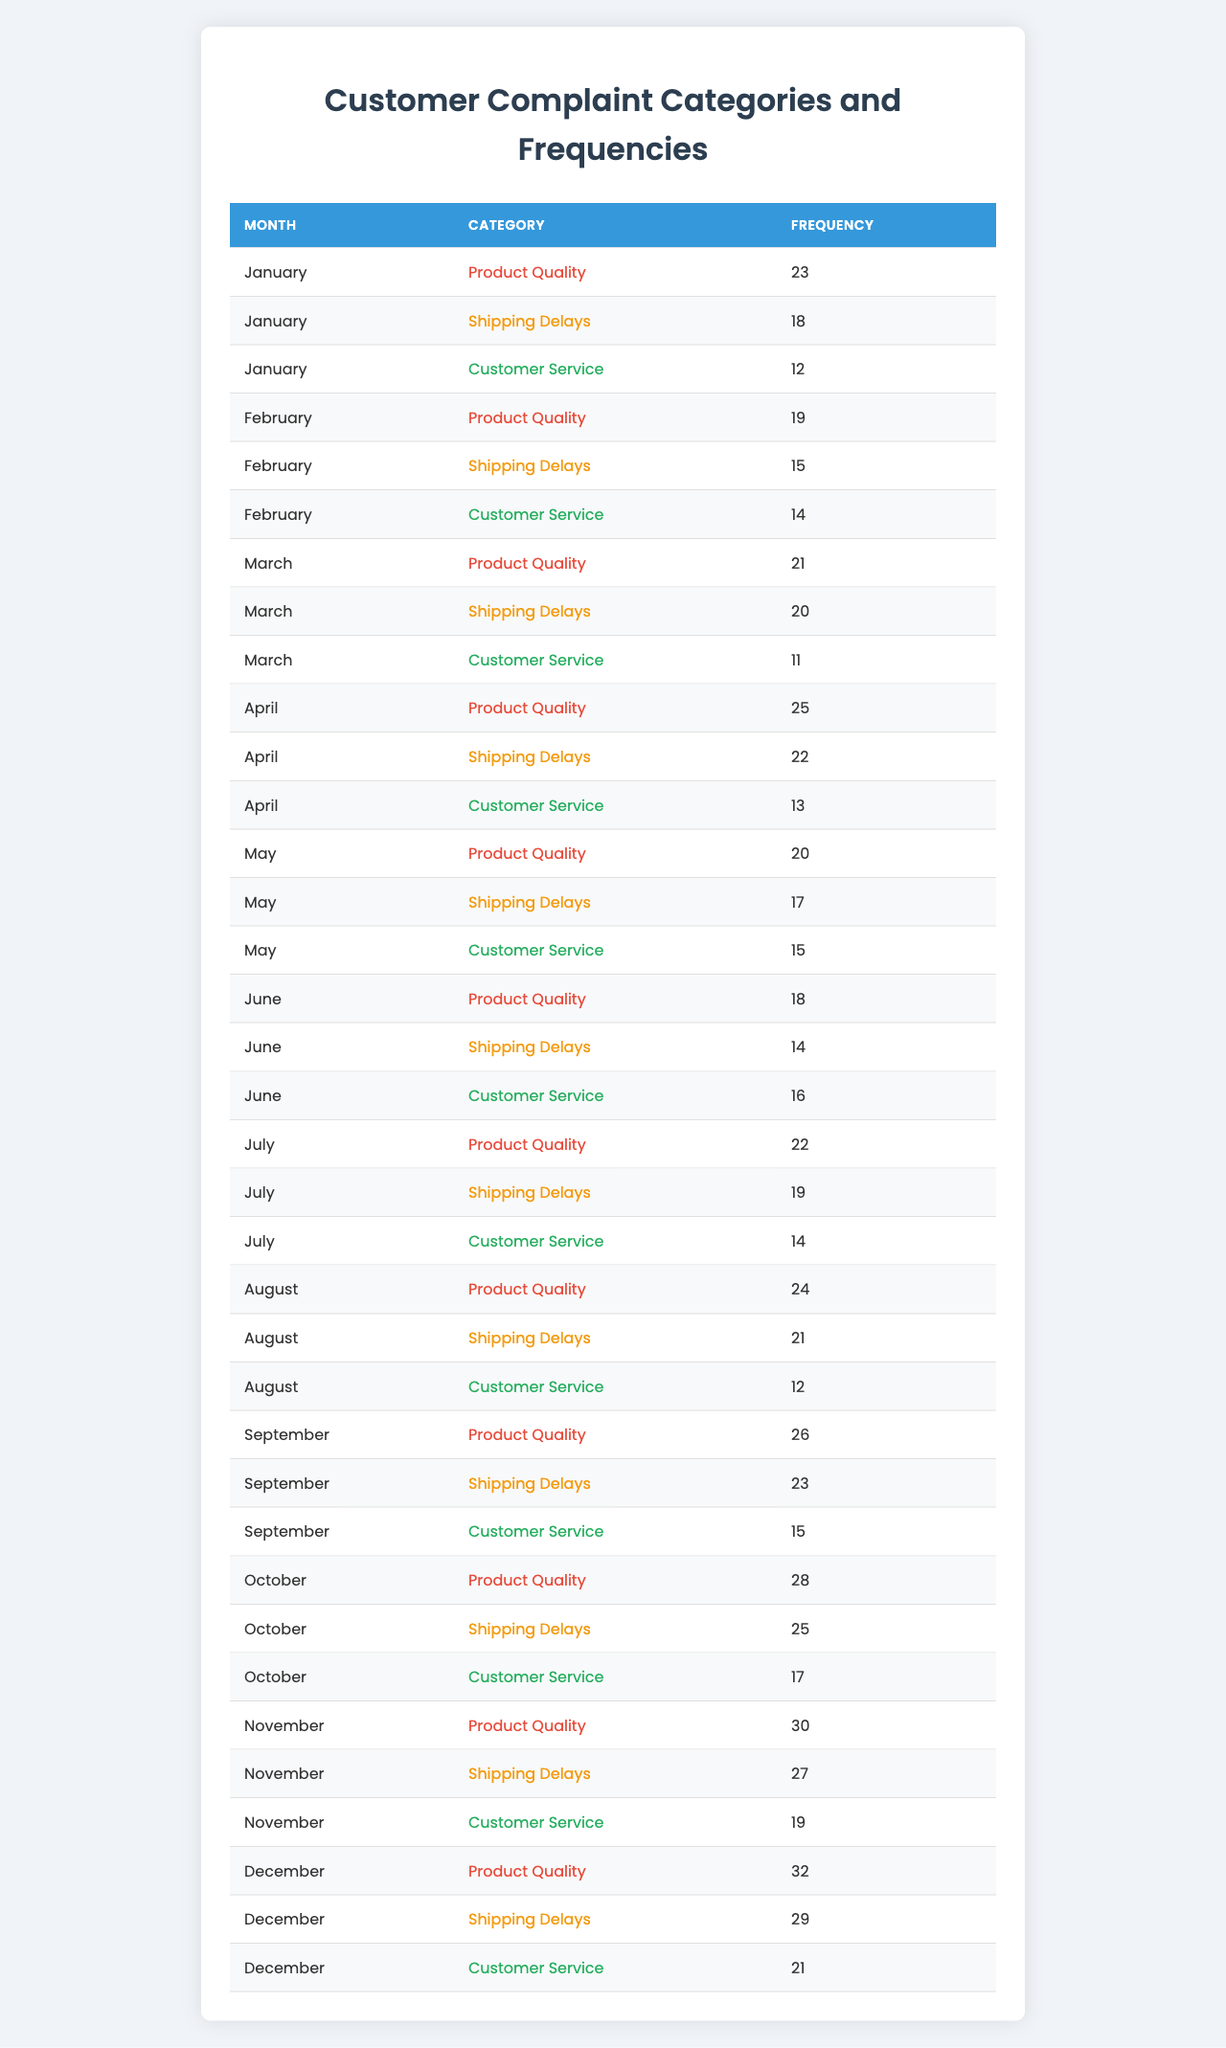What was the most common customer complaint category in December? In December, the table shows three categories: Product Quality (32), Shipping Delays (29), and Customer Service (21). The highest frequency is for Product Quality with 32 complaints.
Answer: Product Quality Which month had the highest frequency of "Customer Service" complaints? Looking at the table, the frequencies for Customer Service are: January (12), February (14), March (11), April (13), May (15), June (16), July (14), August (12), September (15), October (17), November (19), December (21). December had the highest frequency with 21 complaints.
Answer: December What is the total number of complaints received in October across all categories? In October, the table shows the following frequencies: Product Quality (28), Shipping Delays (25), and Customer Service (17). Adding them together: 28 + 25 + 17 = 70.
Answer: 70 How many total complaints were recorded for "Shipping Delays" from January to December? The frequencies for Shipping Delays are: January (18), February (15), March (20), April (22), May (17), June (14), July (19), August (21), September (23), October (25), November (27), December (29). To find the total: 18 + 15 + 20 + 22 + 17 + 14 + 19 + 21 + 23 + 25 + 27 + 29 =  350.
Answer: 350 In which month did "Product Quality" complaints peak, and what was the frequency? Reviewing the table, Product Quality frequencies are: January (23), February (19), March (21), April (25), May (20), June (18), July (22), August (24), September (26), October (28), November (30), December (32). The peak was in December with 32 complaints.
Answer: December, 32 Was there ever a month when "Customer Service" complaints were above 20? By looking at the Customer Service complaints: January (12), February (14), March (11), April (13), May (15), June (16), July (14), August (12), September (15), October (17), November (19), and December (21). Yes, in December, they were above 20 with a frequency of 21.
Answer: Yes What was the average frequency of "Shipping Delays" complaints over the year? The frequencies for Shipping Delays are: January (18), February (15), March (20), April (22), May (17), June (14), July (19), August (21), September (23), October (25), November (27), December (29). First, sum these frequencies: 18 + 15 + 20 + 22 + 17 + 14 + 19 + 21 + 23 + 25 + 27 + 29 =  350. Then divide by 12 months: 350 / 12 = 29.17 (rounded to two decimal places).
Answer: 29.17 Which complaint category consistently had the lowest frequency each month over the entire year? By examining each month, Customer Service consistently had lower numbers than the other categories in several months but did not have the lowest in all months; for instance, in March it had the lowest frequency of 11. Reviewing all categories for the year, it cannot be conclusively assigned to just one category. Therefore, Shipping Delays did have lower frequencies in certain months but had higher frequencies on average compared to Customer Service.
Answer: No single lowest category overall 